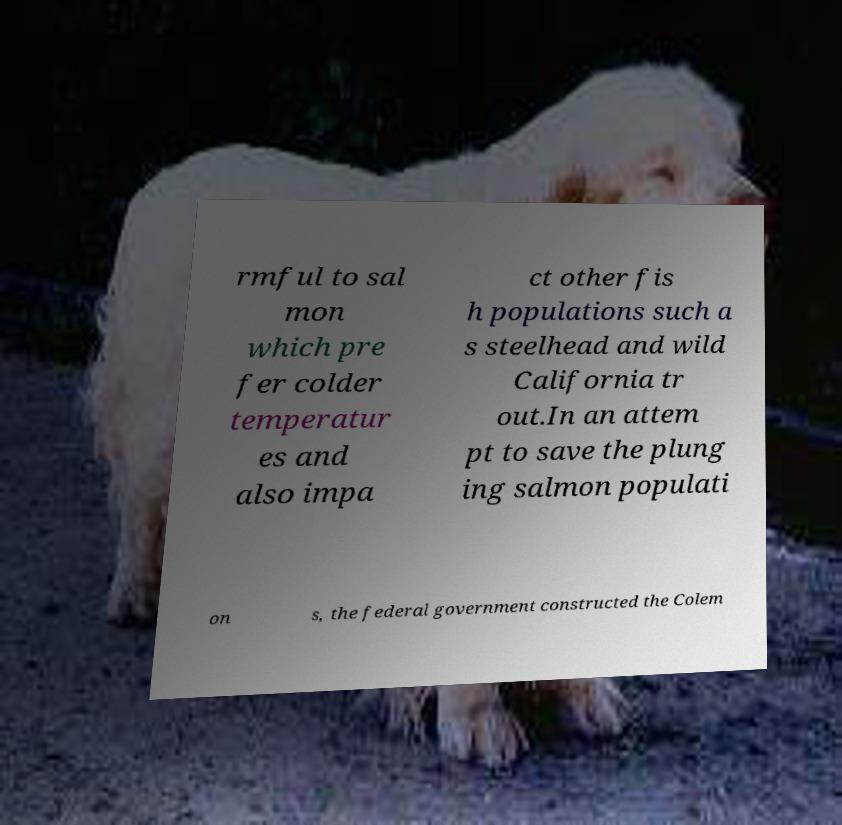Please read and relay the text visible in this image. What does it say? rmful to sal mon which pre fer colder temperatur es and also impa ct other fis h populations such a s steelhead and wild California tr out.In an attem pt to save the plung ing salmon populati on s, the federal government constructed the Colem 